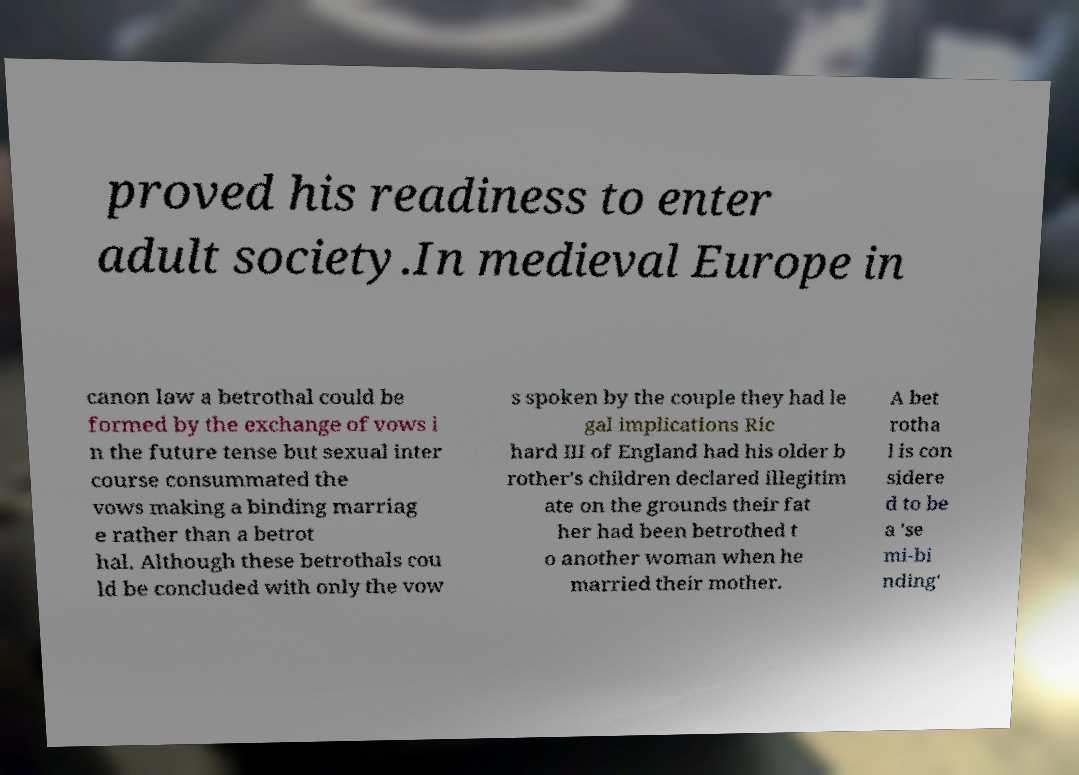Can you accurately transcribe the text from the provided image for me? proved his readiness to enter adult society.In medieval Europe in canon law a betrothal could be formed by the exchange of vows i n the future tense but sexual inter course consummated the vows making a binding marriag e rather than a betrot hal. Although these betrothals cou ld be concluded with only the vow s spoken by the couple they had le gal implications Ric hard III of England had his older b rother's children declared illegitim ate on the grounds their fat her had been betrothed t o another woman when he married their mother. A bet rotha l is con sidere d to be a 'se mi-bi nding' 